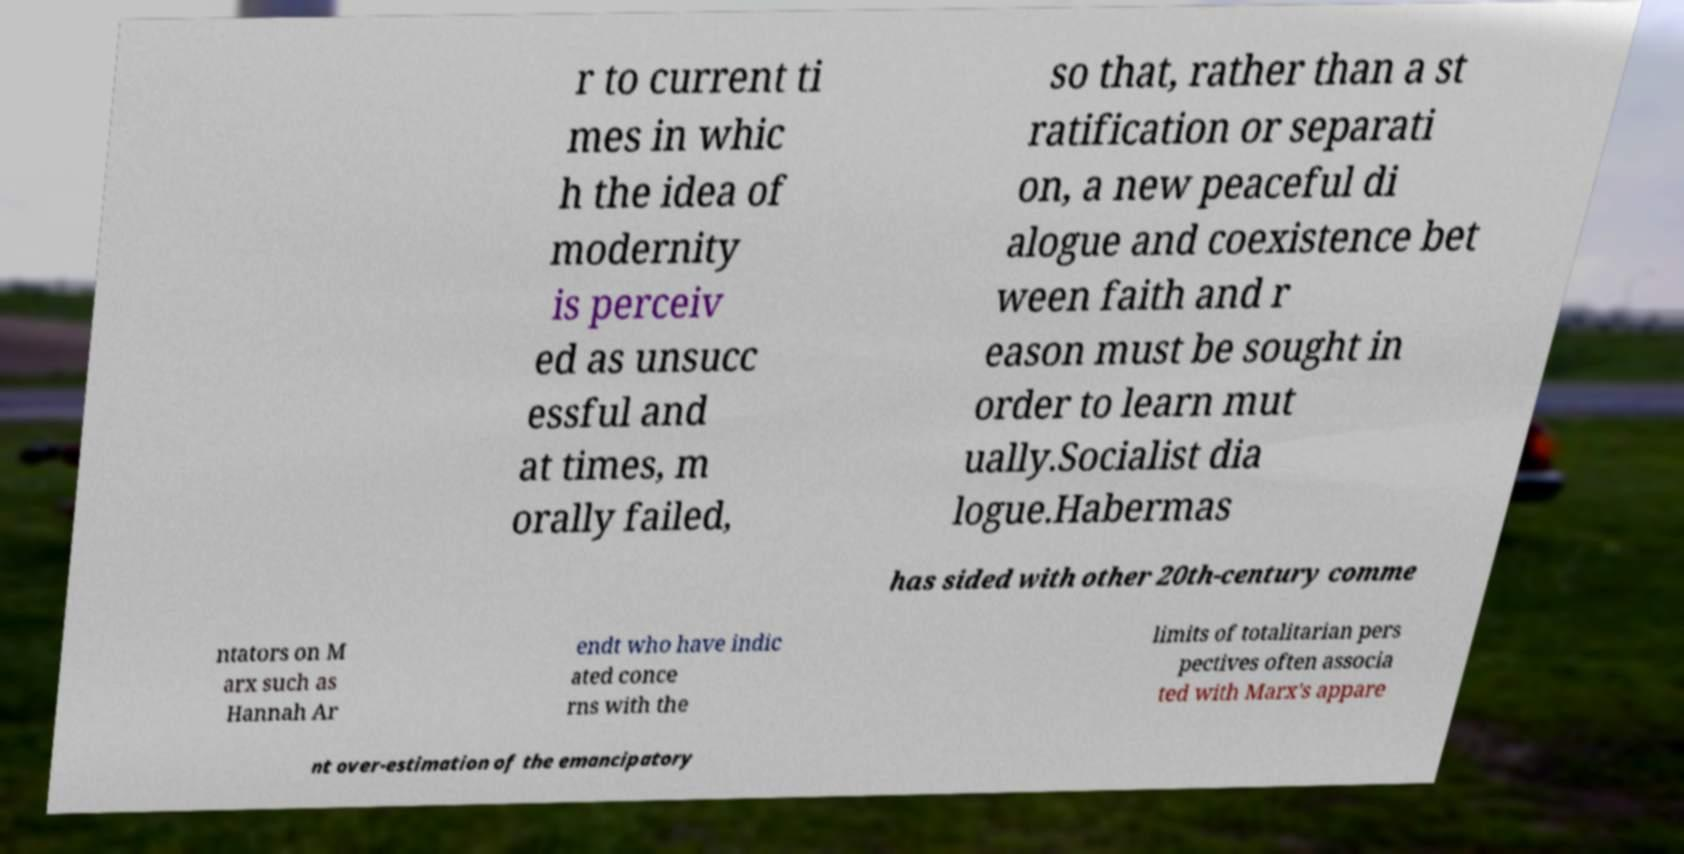For documentation purposes, I need the text within this image transcribed. Could you provide that? r to current ti mes in whic h the idea of modernity is perceiv ed as unsucc essful and at times, m orally failed, so that, rather than a st ratification or separati on, a new peaceful di alogue and coexistence bet ween faith and r eason must be sought in order to learn mut ually.Socialist dia logue.Habermas has sided with other 20th-century comme ntators on M arx such as Hannah Ar endt who have indic ated conce rns with the limits of totalitarian pers pectives often associa ted with Marx's appare nt over-estimation of the emancipatory 